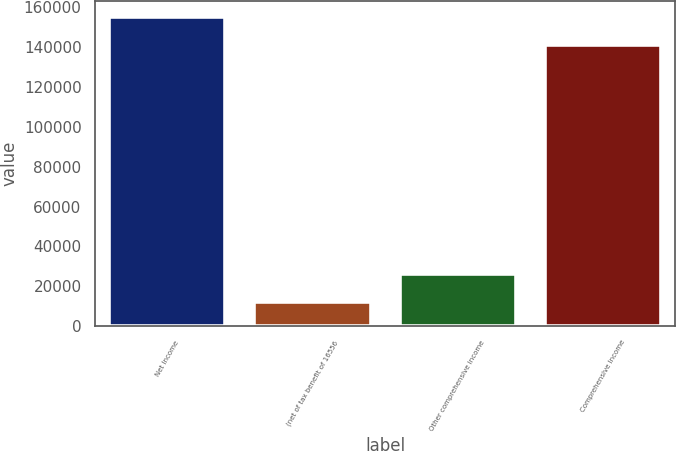Convert chart. <chart><loc_0><loc_0><loc_500><loc_500><bar_chart><fcel>Net Income<fcel>(net of tax benefit of 16556<fcel>Other comprehensive income<fcel>Comprehensive Income<nl><fcel>155255<fcel>11906<fcel>26020.1<fcel>141141<nl></chart> 